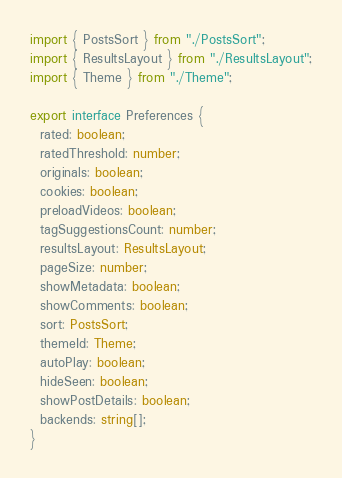<code> <loc_0><loc_0><loc_500><loc_500><_TypeScript_>import { PostsSort } from "./PostsSort";
import { ResultsLayout } from "./ResultsLayout";
import { Theme } from "./Theme";

export interface Preferences {
  rated: boolean;
  ratedThreshold: number;
  originals: boolean;
  cookies: boolean;
  preloadVideos: boolean;
  tagSuggestionsCount: number;
  resultsLayout: ResultsLayout;
  pageSize: number;
  showMetadata: boolean;
  showComments: boolean;
  sort: PostsSort;
  themeId: Theme;
  autoPlay: boolean;
  hideSeen: boolean;
  showPostDetails: boolean;
  backends: string[];
}
</code> 